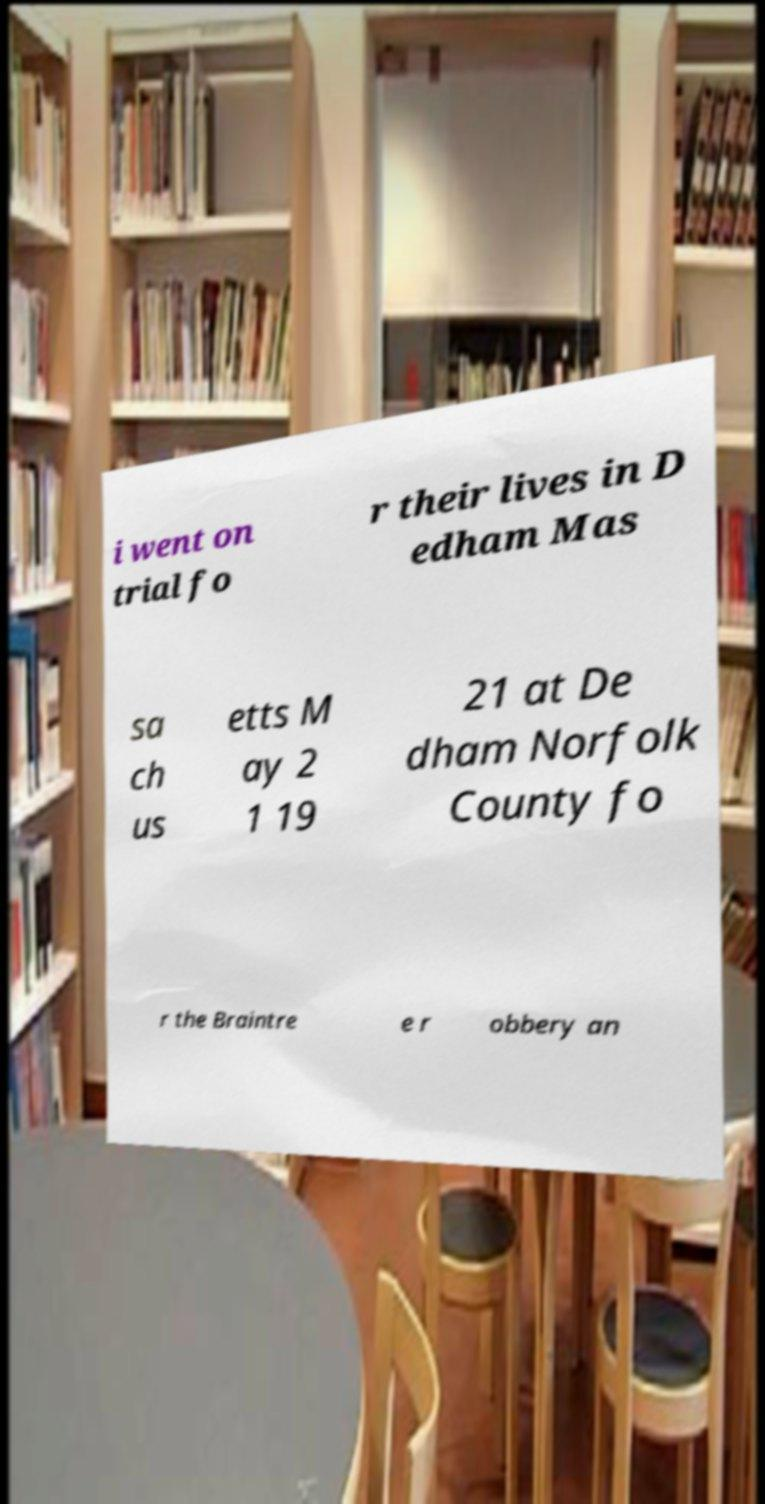Can you read and provide the text displayed in the image?This photo seems to have some interesting text. Can you extract and type it out for me? i went on trial fo r their lives in D edham Mas sa ch us etts M ay 2 1 19 21 at De dham Norfolk County fo r the Braintre e r obbery an 